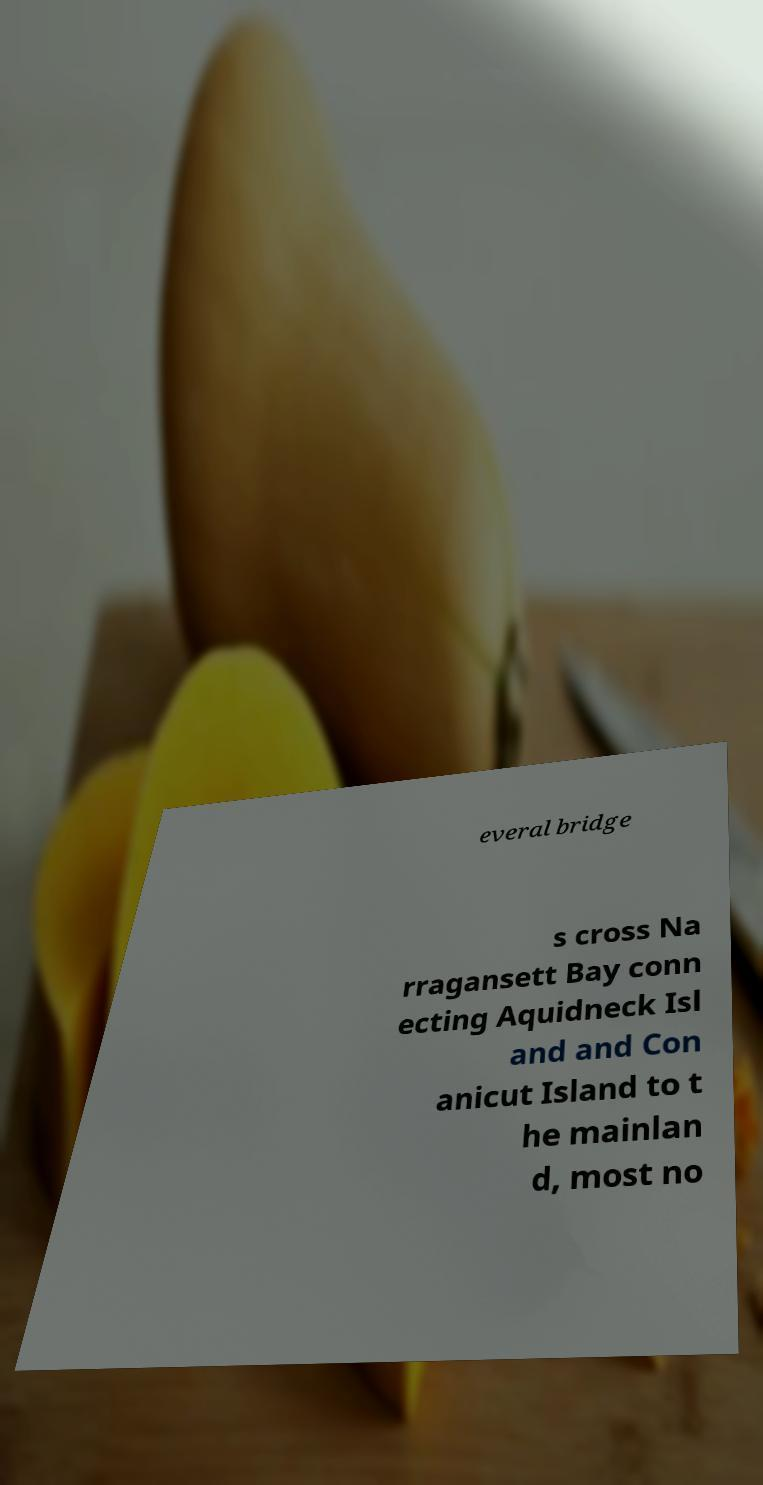For documentation purposes, I need the text within this image transcribed. Could you provide that? everal bridge s cross Na rragansett Bay conn ecting Aquidneck Isl and and Con anicut Island to t he mainlan d, most no 